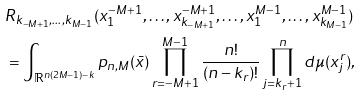<formula> <loc_0><loc_0><loc_500><loc_500>& R _ { k _ { - M + 1 } , \dots , k _ { M - 1 } } ( x _ { 1 } ^ { - M + 1 } , \dots , x _ { k _ { - M + 1 } } ^ { - M + 1 } , \dots , x _ { 1 } ^ { M - 1 } , \dots , x _ { k _ { M - 1 } } ^ { M - 1 } ) \\ & = \int _ { \mathbb { R } ^ { n ( 2 M - 1 ) - k } } p _ { n , M } ( \bar { x } ) \prod _ { r = - M + 1 } ^ { M - 1 } \frac { n ! } { ( n - k _ { r } ) ! } \prod _ { j = k _ { r } + 1 } ^ { n } d \mu ( x _ { j } ^ { r } ) ,</formula> 